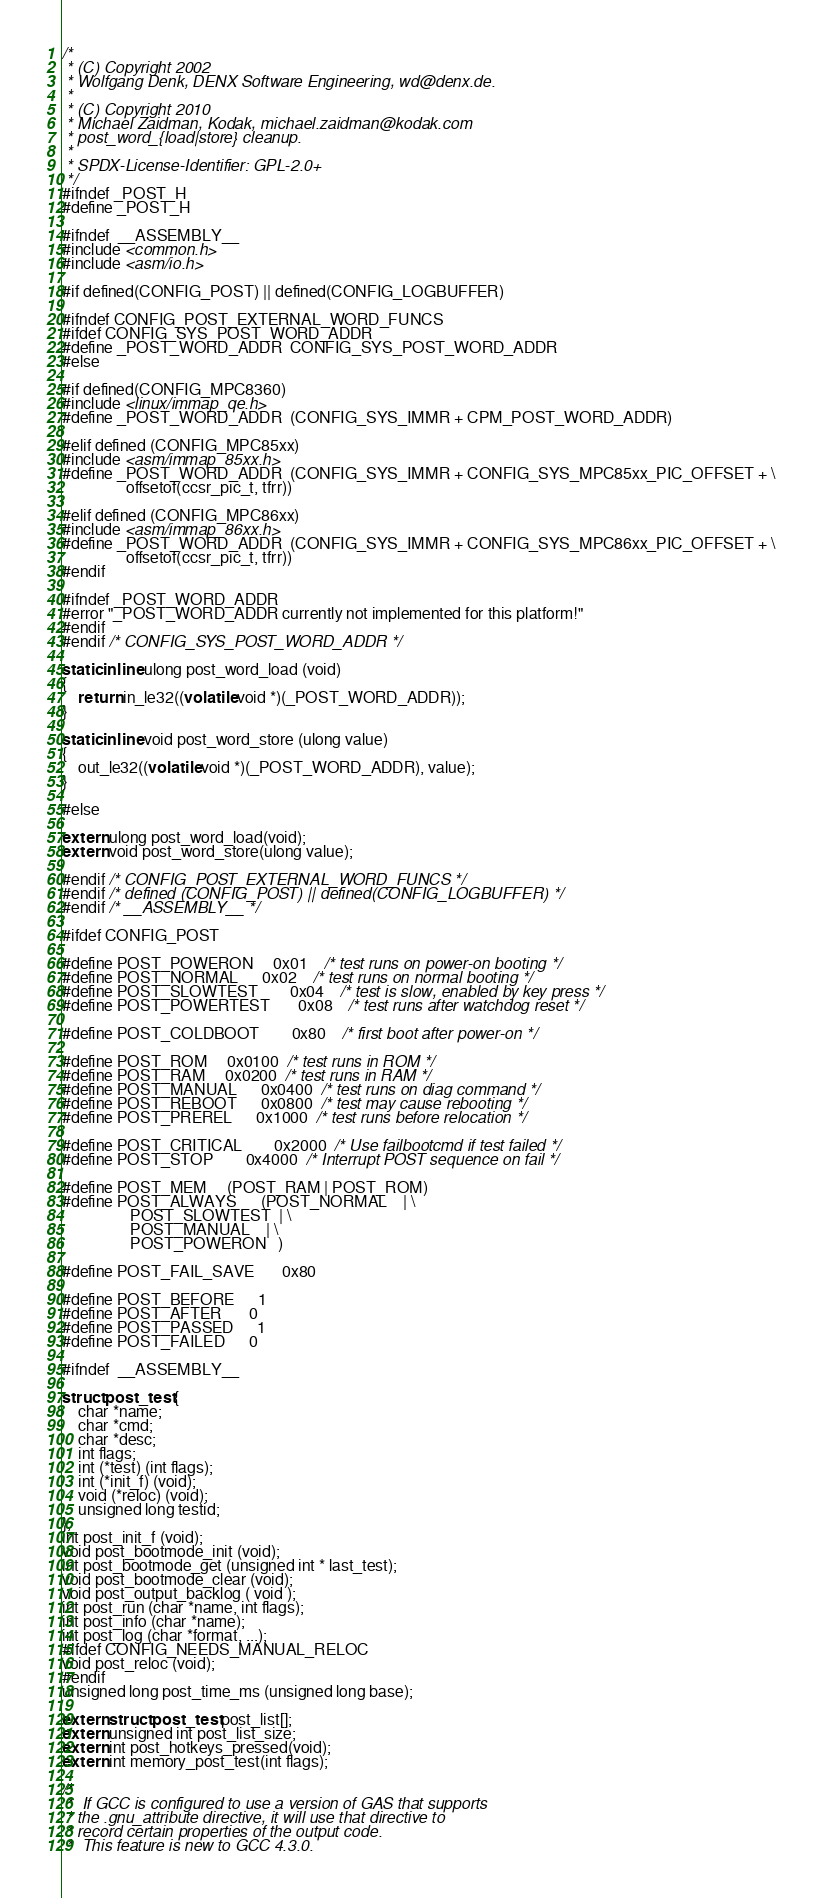Convert code to text. <code><loc_0><loc_0><loc_500><loc_500><_C_>/*
 * (C) Copyright 2002
 * Wolfgang Denk, DENX Software Engineering, wd@denx.de.
 *
 * (C) Copyright 2010
 * Michael Zaidman, Kodak, michael.zaidman@kodak.com
 * post_word_{load|store} cleanup.
 *
 * SPDX-License-Identifier:	GPL-2.0+
 */
#ifndef _POST_H
#define _POST_H

#ifndef	__ASSEMBLY__
#include <common.h>
#include <asm/io.h>

#if defined(CONFIG_POST) || defined(CONFIG_LOGBUFFER)

#ifndef CONFIG_POST_EXTERNAL_WORD_FUNCS
#ifdef CONFIG_SYS_POST_WORD_ADDR
#define _POST_WORD_ADDR	CONFIG_SYS_POST_WORD_ADDR
#else

#if defined(CONFIG_MPC8360)
#include <linux/immap_qe.h>
#define _POST_WORD_ADDR	(CONFIG_SYS_IMMR + CPM_POST_WORD_ADDR)

#elif defined (CONFIG_MPC85xx)
#include <asm/immap_85xx.h>
#define _POST_WORD_ADDR	(CONFIG_SYS_IMMR + CONFIG_SYS_MPC85xx_PIC_OFFSET + \
				offsetof(ccsr_pic_t, tfrr))

#elif defined (CONFIG_MPC86xx)
#include <asm/immap_86xx.h>
#define _POST_WORD_ADDR	(CONFIG_SYS_IMMR + CONFIG_SYS_MPC86xx_PIC_OFFSET + \
				offsetof(ccsr_pic_t, tfrr))
#endif

#ifndef _POST_WORD_ADDR
#error "_POST_WORD_ADDR currently not implemented for this platform!"
#endif
#endif /* CONFIG_SYS_POST_WORD_ADDR */

static inline ulong post_word_load (void)
{
	return in_le32((volatile void *)(_POST_WORD_ADDR));
}

static inline void post_word_store (ulong value)
{
	out_le32((volatile void *)(_POST_WORD_ADDR), value);
}

#else

extern ulong post_word_load(void);
extern void post_word_store(ulong value);

#endif /* CONFIG_POST_EXTERNAL_WORD_FUNCS */
#endif /* defined (CONFIG_POST) || defined(CONFIG_LOGBUFFER) */
#endif /* __ASSEMBLY__ */

#ifdef CONFIG_POST

#define POST_POWERON		0x01	/* test runs on power-on booting */
#define POST_NORMAL		0x02	/* test runs on normal booting */
#define POST_SLOWTEST		0x04	/* test is slow, enabled by key press */
#define POST_POWERTEST		0x08	/* test runs after watchdog reset */

#define POST_COLDBOOT		0x80	/* first boot after power-on */

#define POST_ROM		0x0100	/* test runs in ROM */
#define POST_RAM		0x0200	/* test runs in RAM */
#define POST_MANUAL		0x0400	/* test runs on diag command */
#define POST_REBOOT		0x0800	/* test may cause rebooting */
#define POST_PREREL		0x1000  /* test runs before relocation */

#define POST_CRITICAL		0x2000	/* Use failbootcmd if test failed */
#define POST_STOP		0x4000	/* Interrupt POST sequence on fail */

#define POST_MEM		(POST_RAM | POST_ROM)
#define POST_ALWAYS		(POST_NORMAL	| \
				 POST_SLOWTEST	| \
				 POST_MANUAL	| \
				 POST_POWERON	)

#define POST_FAIL_SAVE		0x80

#define POST_BEFORE		1
#define POST_AFTER		0
#define POST_PASSED		1
#define POST_FAILED		0

#ifndef	__ASSEMBLY__

struct post_test {
	char *name;
	char *cmd;
	char *desc;
	int flags;
	int (*test) (int flags);
	int (*init_f) (void);
	void (*reloc) (void);
	unsigned long testid;
};
int post_init_f (void);
void post_bootmode_init (void);
int post_bootmode_get (unsigned int * last_test);
void post_bootmode_clear (void);
void post_output_backlog ( void );
int post_run (char *name, int flags);
int post_info (char *name);
int post_log (char *format, ...);
#ifdef CONFIG_NEEDS_MANUAL_RELOC
void post_reloc (void);
#endif
unsigned long post_time_ms (unsigned long base);

extern struct post_test post_list[];
extern unsigned int post_list_size;
extern int post_hotkeys_pressed(void);
extern int memory_post_test(int flags);

/*
 *  If GCC is configured to use a version of GAS that supports
 * the .gnu_attribute directive, it will use that directive to
 * record certain properties of the output code.
 *  This feature is new to GCC 4.3.0.</code> 